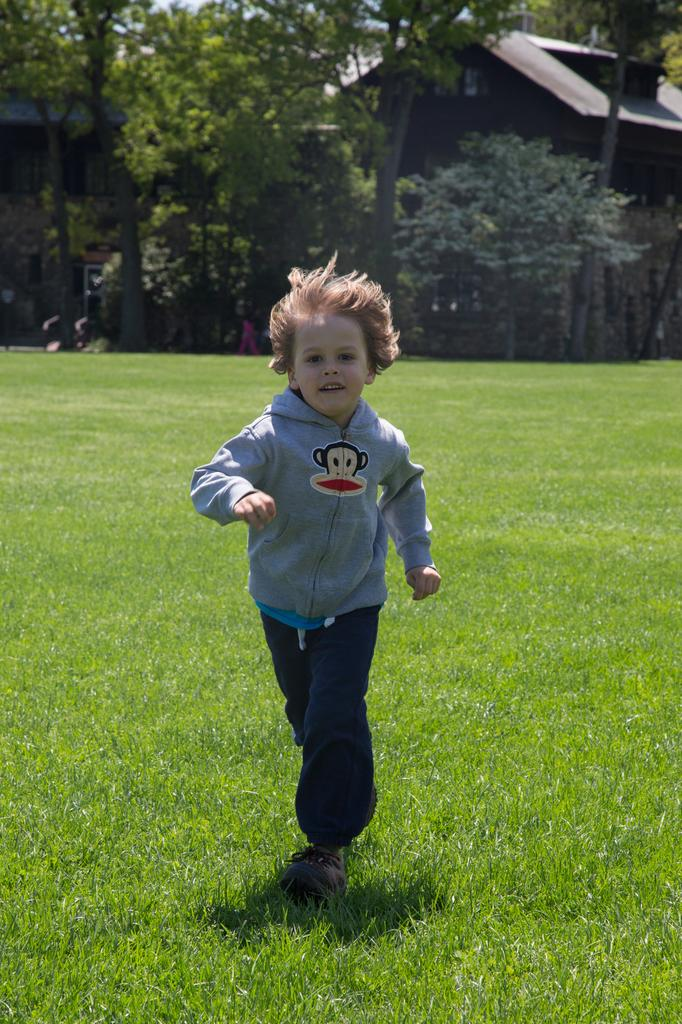What is the main subject of the image? The main subject of the image is a kid. What is the kid doing in the image? The kid is running on the grass in the image. What is the kid's facial expression in the image? The kid is smiling in the image. What can be seen in the background of the image? There are houses, trees, and plants in the background of the image. What type of truck can be seen in the image? There is no truck present in the image; it features a kid running on the grass. What kind of seed is the kid planting in the image? There is no seed or planting activity depicted in the image; the kid is simply running on the grass. 